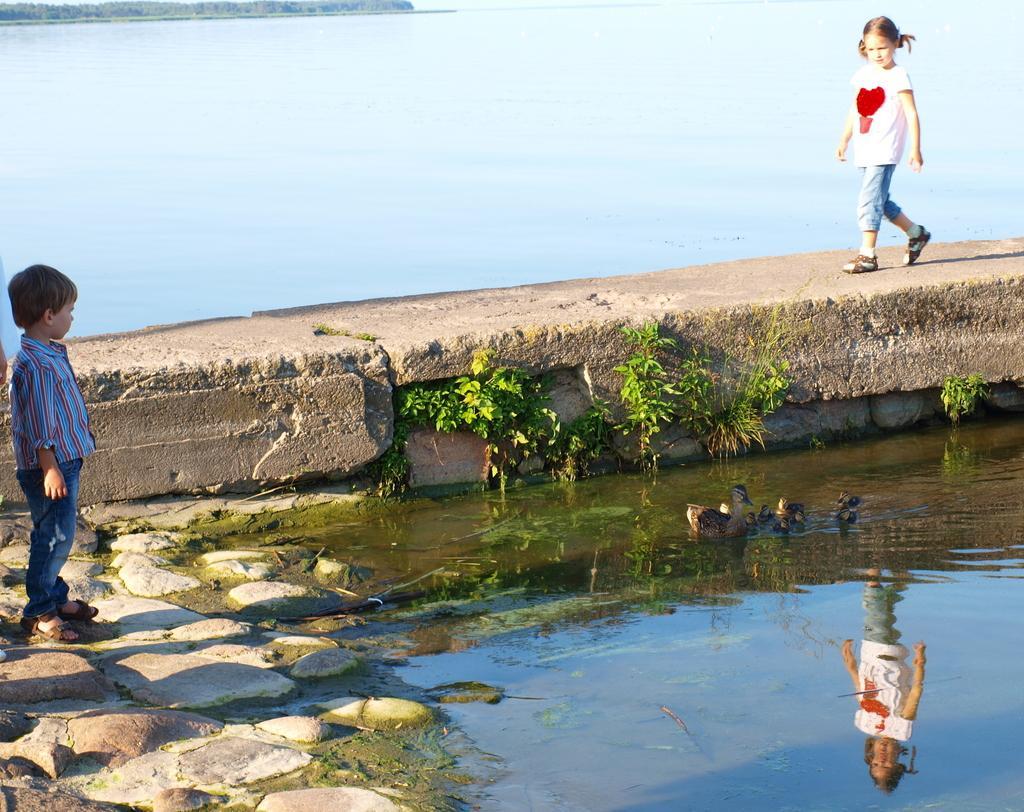Can you describe this image briefly? This picture might be taken outside of the city. In this image, on the right side, we can see a girl walking on the bridge. On the left side, we can also see a boy standing on the stones. In the background, we can see water in a lake, trees, at the bottom, we can see mirror image of a girl in the water. 